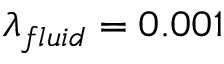Convert formula to latex. <formula><loc_0><loc_0><loc_500><loc_500>\lambda _ { f l u i d } = 0 . 0 0 1</formula> 